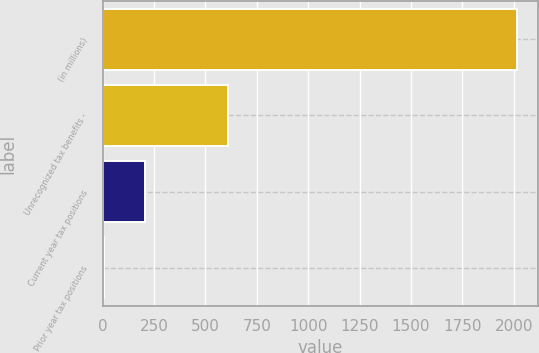Convert chart. <chart><loc_0><loc_0><loc_500><loc_500><bar_chart><fcel>(in millions)<fcel>Unrecognized tax benefits -<fcel>Current year tax positions<fcel>Prior year tax positions<nl><fcel>2017<fcel>610<fcel>208<fcel>7<nl></chart> 